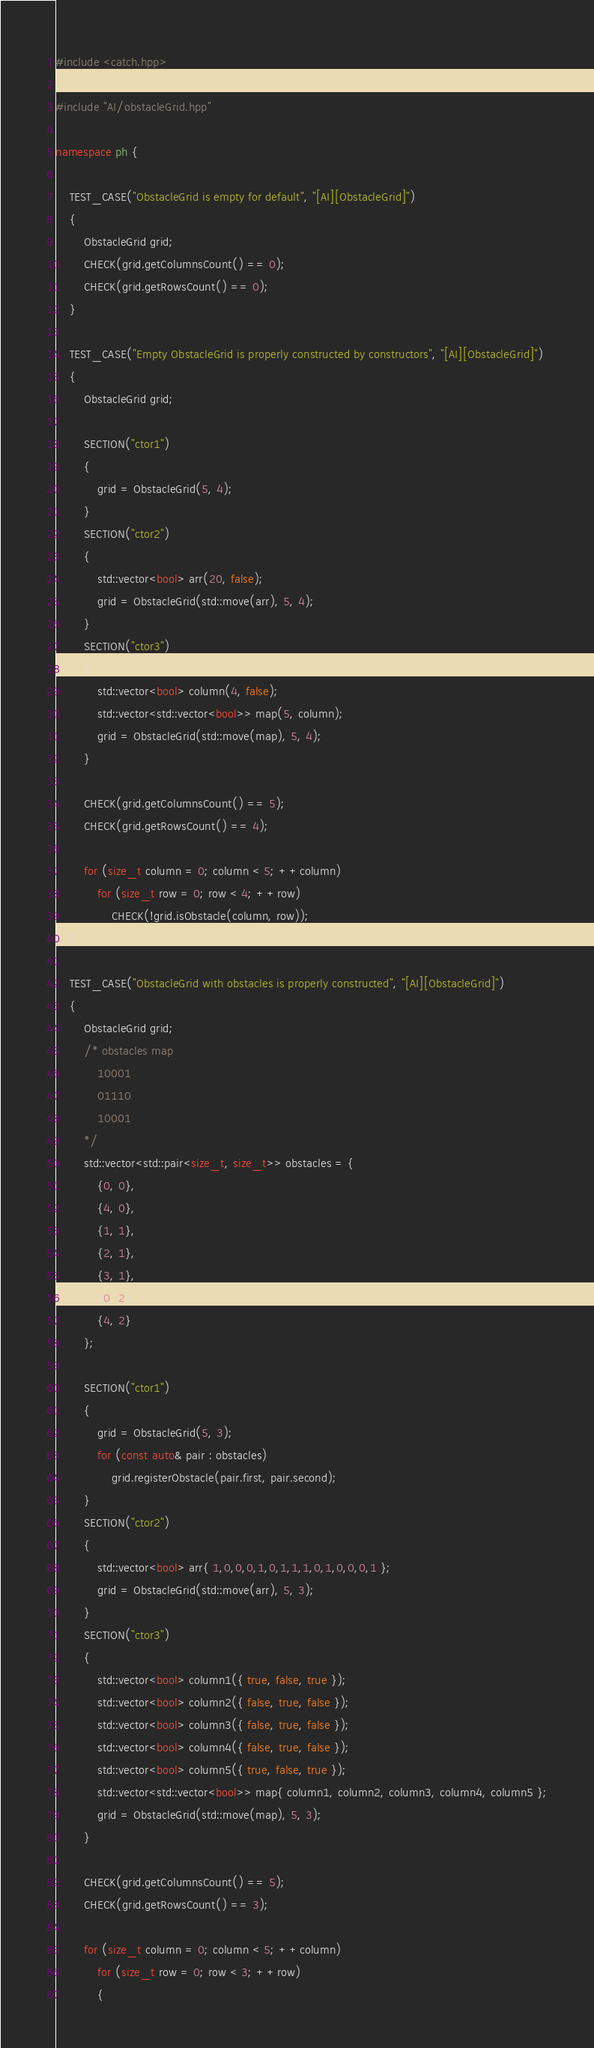Convert code to text. <code><loc_0><loc_0><loc_500><loc_500><_C++_>#include <catch.hpp>

#include "AI/obstacleGrid.hpp"

namespace ph {

	TEST_CASE("ObstacleGrid is empty for default", "[AI][ObstacleGrid]")
	{
		ObstacleGrid grid;
		CHECK(grid.getColumnsCount() == 0);
		CHECK(grid.getRowsCount() == 0);
	}

	TEST_CASE("Empty ObstacleGrid is properly constructed by constructors", "[AI][ObstacleGrid]")
	{
		ObstacleGrid grid;

		SECTION("ctor1")
		{
			grid = ObstacleGrid(5, 4);
		}
		SECTION("ctor2")
		{
			std::vector<bool> arr(20, false);
			grid = ObstacleGrid(std::move(arr), 5, 4);
		}
		SECTION("ctor3")
		{
			std::vector<bool> column(4, false);
			std::vector<std::vector<bool>> map(5, column);
			grid = ObstacleGrid(std::move(map), 5, 4);
		}

		CHECK(grid.getColumnsCount() == 5);
		CHECK(grid.getRowsCount() == 4);

		for (size_t column = 0; column < 5; ++column)
			for (size_t row = 0; row < 4; ++row)
				CHECK(!grid.isObstacle(column, row));
	}

	TEST_CASE("ObstacleGrid with obstacles is properly constructed", "[AI][ObstacleGrid]")
	{
		ObstacleGrid grid;
		/* obstacles map
			10001
			01110
			10001
		*/
		std::vector<std::pair<size_t, size_t>> obstacles = {
			{0, 0},
			{4, 0},
			{1, 1},
			{2, 1},
			{3, 1},
			{0, 2},
			{4, 2}
		};

		SECTION("ctor1")
		{
			grid = ObstacleGrid(5, 3);
			for (const auto& pair : obstacles)
				grid.registerObstacle(pair.first, pair.second);
		}
		SECTION("ctor2")
		{
			std::vector<bool> arr{ 1,0,0,0,1,0,1,1,1,0,1,0,0,0,1 };
			grid = ObstacleGrid(std::move(arr), 5, 3);
		}
		SECTION("ctor3")
		{
			std::vector<bool> column1({ true, false, true });
			std::vector<bool> column2({ false, true, false });
			std::vector<bool> column3({ false, true, false });
			std::vector<bool> column4({ false, true, false });
			std::vector<bool> column5({ true, false, true });
			std::vector<std::vector<bool>> map{ column1, column2, column3, column4, column5 };
			grid = ObstacleGrid(std::move(map), 5, 3);
		}

		CHECK(grid.getColumnsCount() == 5);
		CHECK(grid.getRowsCount() == 3);

		for (size_t column = 0; column < 5; ++column)
			for (size_t row = 0; row < 3; ++row)
			{</code> 